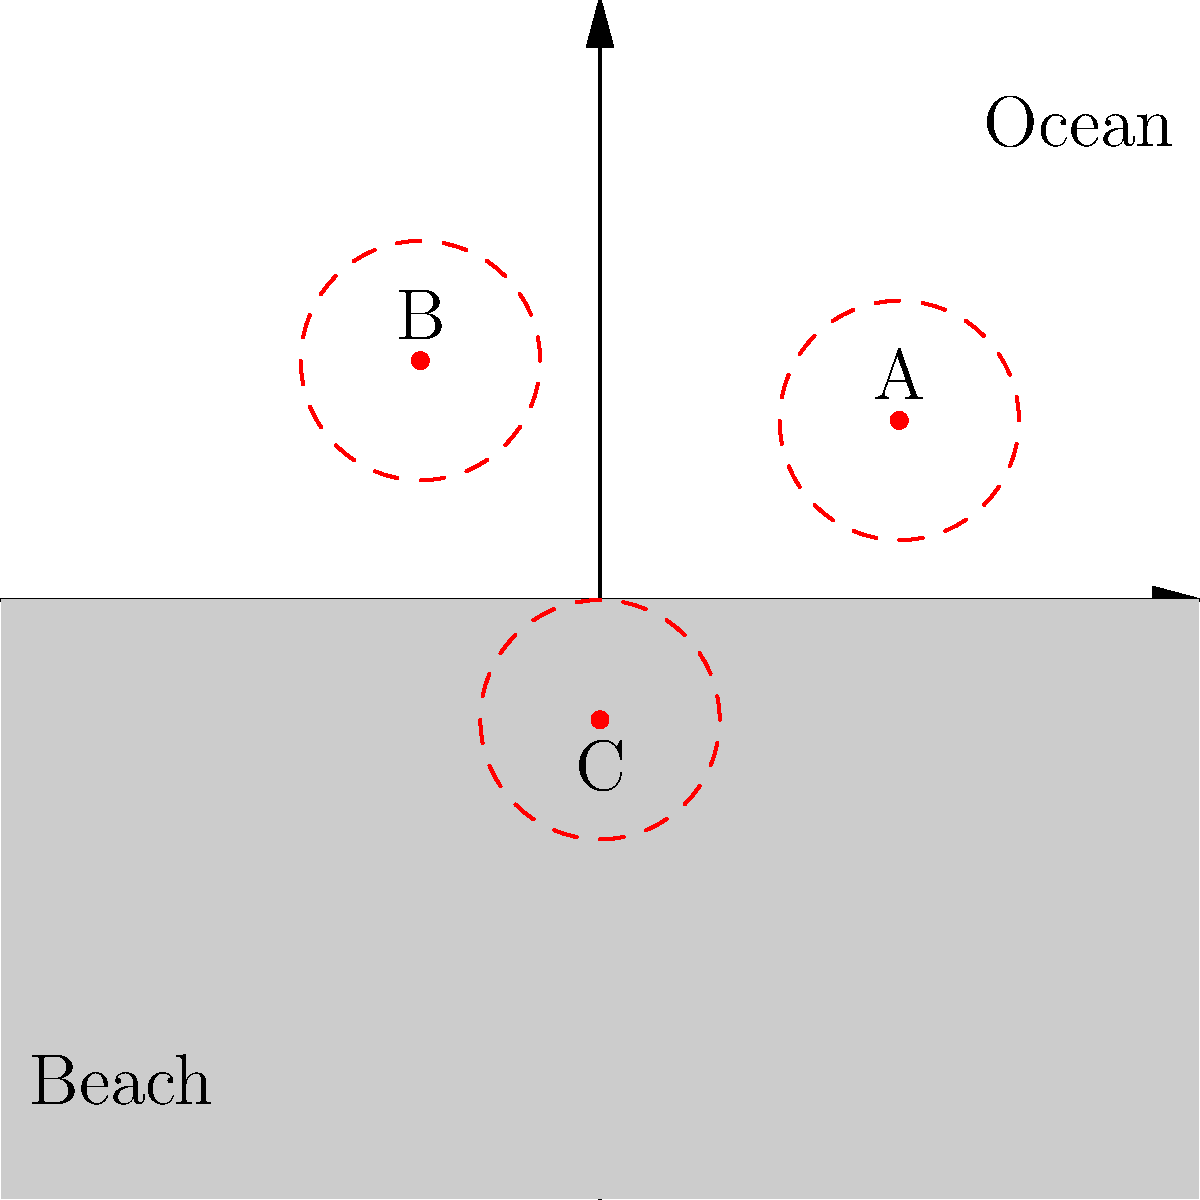A map of a sea turtle nesting ground shows three light sources (A, B, and C) affecting the beach area. Each light source impacts a circular area with a radius of 2 units. Estimate the total area of the nesting ground affected by light pollution. Assume that overlapping areas are only counted once. To solve this problem, we'll follow these steps:

1) First, we need to calculate the area of a single circle:
   Area of one circle = $\pi r^2 = \pi (2)^2 = 4\pi$ square units

2) If the circles didn't overlap, the total area would be:
   $3 * 4\pi = 12\pi$ square units

3) However, we can see from the diagram that there is some overlap between circles A and B, and between B and C.

4) To estimate the overlap, we can use the formula for the area of intersection of two circles:
   $A = 2r^2 \arccos(\frac{d}{2r}) - d\sqrt{r^2 - \frac{d^2}{4}}$
   where $r$ is the radius and $d$ is the distance between circle centers.

5) The distance between A and B is approximately 8 units, and between B and C is about 7 units.

6) Plugging these into the formula:
   For A and B: $A_{AB} \approx 2(2^2) \arccos(\frac{8}{2(2)}) - 8\sqrt{2^2 - \frac{8^2}{4}} \approx 0.39$ sq units
   For B and C: $A_{BC} \approx 2(2^2) \arccos(\frac{7}{2(2)}) - 7\sqrt{2^2 - \frac{7^2}{4}} \approx 0.91$ sq units

7) The total area affected is approximately:
   $12\pi - 0.39 - 0.91 \approx 36.5$ square units

Therefore, the estimated area of the nesting ground affected by light pollution is about 36.5 square units.
Answer: $36.5$ square units 